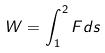Convert formula to latex. <formula><loc_0><loc_0><loc_500><loc_500>W = \int _ { 1 } ^ { 2 } F d s</formula> 